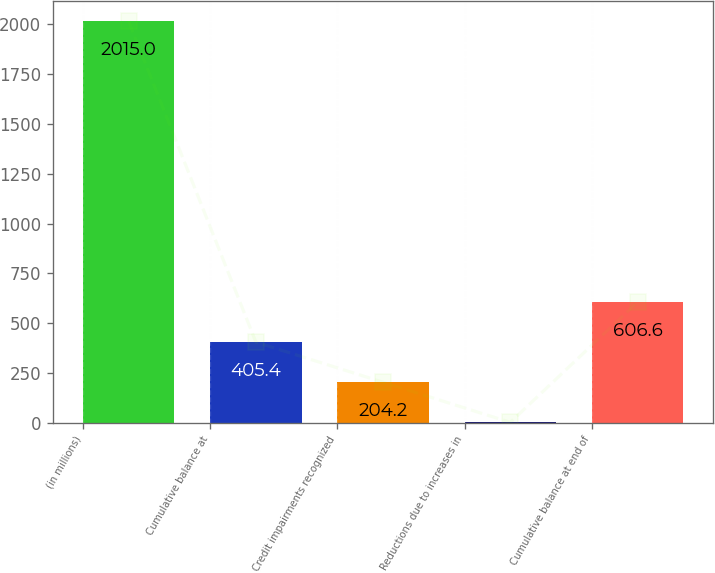Convert chart. <chart><loc_0><loc_0><loc_500><loc_500><bar_chart><fcel>(in millions)<fcel>Cumulative balance at<fcel>Credit impairments recognized<fcel>Reductions due to increases in<fcel>Cumulative balance at end of<nl><fcel>2015<fcel>405.4<fcel>204.2<fcel>3<fcel>606.6<nl></chart> 